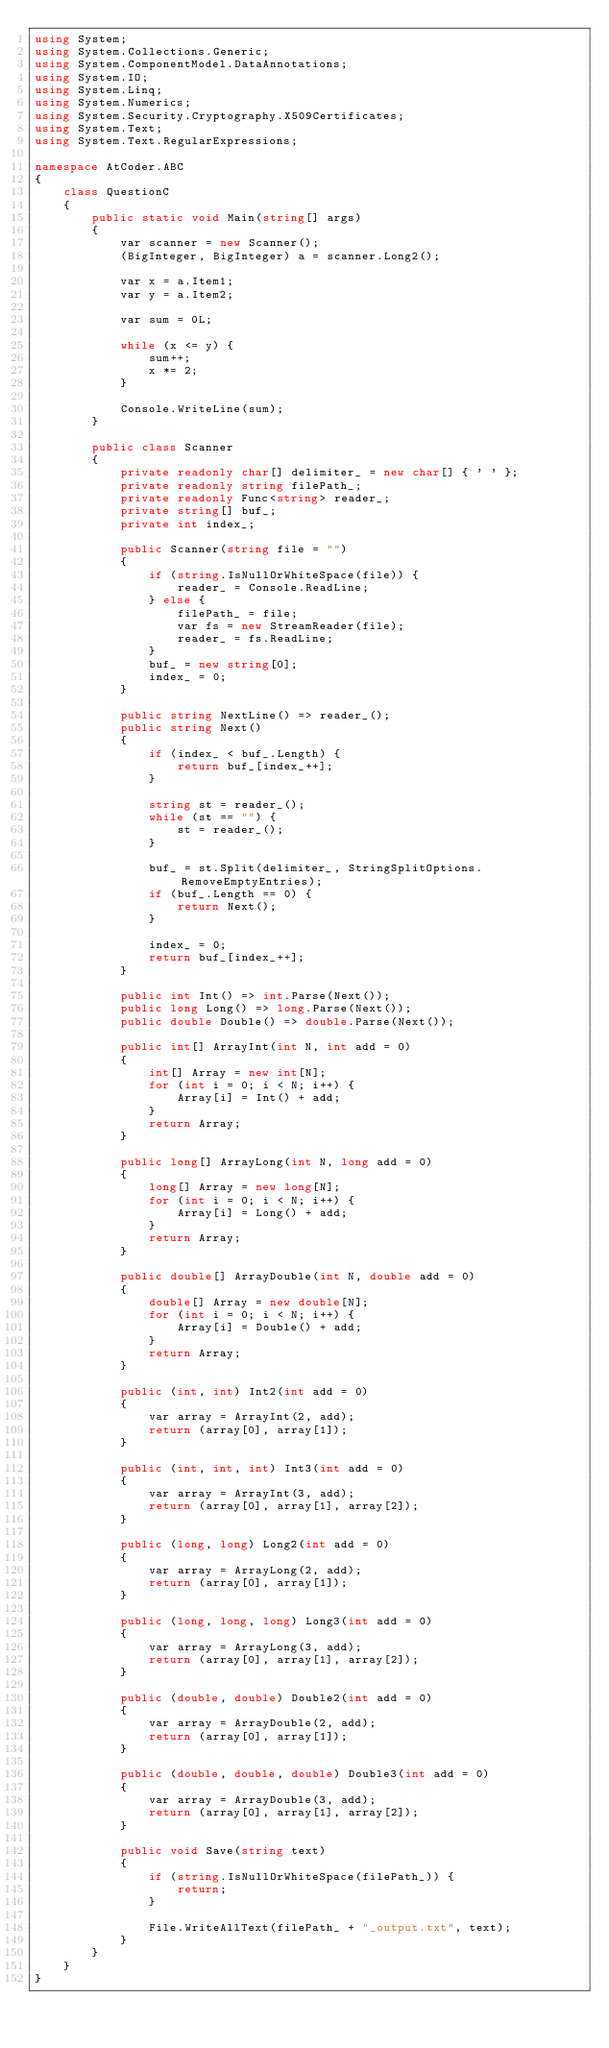<code> <loc_0><loc_0><loc_500><loc_500><_C#_>using System;
using System.Collections.Generic;
using System.ComponentModel.DataAnnotations;
using System.IO;
using System.Linq;
using System.Numerics;
using System.Security.Cryptography.X509Certificates;
using System.Text;
using System.Text.RegularExpressions;

namespace AtCoder.ABC
{
	class QuestionC
	{
		public static void Main(string[] args)
		{
			var scanner = new Scanner();
			(BigInteger, BigInteger) a = scanner.Long2();

			var x = a.Item1;
			var y = a.Item2;

			var sum = 0L;

			while (x <= y) {
				sum++;
				x *= 2;
			}

			Console.WriteLine(sum);
		}

		public class Scanner
		{
			private readonly char[] delimiter_ = new char[] { ' ' };
			private readonly string filePath_;
			private readonly Func<string> reader_;
			private string[] buf_;
			private int index_;

			public Scanner(string file = "")
			{
				if (string.IsNullOrWhiteSpace(file)) {
					reader_ = Console.ReadLine;
				} else {
					filePath_ = file;
					var fs = new StreamReader(file);
					reader_ = fs.ReadLine;
				}
				buf_ = new string[0];
				index_ = 0;
			}

			public string NextLine() => reader_();
			public string Next()
			{
				if (index_ < buf_.Length) {
					return buf_[index_++];
				}

				string st = reader_();
				while (st == "") {
					st = reader_();
				}

				buf_ = st.Split(delimiter_, StringSplitOptions.RemoveEmptyEntries);
				if (buf_.Length == 0) {
					return Next();
				}

				index_ = 0;
				return buf_[index_++];
			}

			public int Int() => int.Parse(Next());
			public long Long() => long.Parse(Next());
			public double Double() => double.Parse(Next());

			public int[] ArrayInt(int N, int add = 0)
			{
				int[] Array = new int[N];
				for (int i = 0; i < N; i++) {
					Array[i] = Int() + add;
				}
				return Array;
			}

			public long[] ArrayLong(int N, long add = 0)
			{
				long[] Array = new long[N];
				for (int i = 0; i < N; i++) {
					Array[i] = Long() + add;
				}
				return Array;
			}

			public double[] ArrayDouble(int N, double add = 0)
			{
				double[] Array = new double[N];
				for (int i = 0; i < N; i++) {
					Array[i] = Double() + add;
				}
				return Array;
			}

			public (int, int) Int2(int add = 0)
			{
				var array = ArrayInt(2, add);
				return (array[0], array[1]);
			}

			public (int, int, int) Int3(int add = 0)
			{
				var array = ArrayInt(3, add);
				return (array[0], array[1], array[2]);
			}

			public (long, long) Long2(int add = 0)
			{
				var array = ArrayLong(2, add);
				return (array[0], array[1]);
			}

			public (long, long, long) Long3(int add = 0)
			{
				var array = ArrayLong(3, add);
				return (array[0], array[1], array[2]);
			}

			public (double, double) Double2(int add = 0)
			{
				var array = ArrayDouble(2, add);
				return (array[0], array[1]);
			}

			public (double, double, double) Double3(int add = 0)
			{
				var array = ArrayDouble(3, add);
				return (array[0], array[1], array[2]);
			}

			public void Save(string text)
			{
				if (string.IsNullOrWhiteSpace(filePath_)) {
					return;
				}

				File.WriteAllText(filePath_ + "_output.txt", text);
			}
		}
	}
}
</code> 